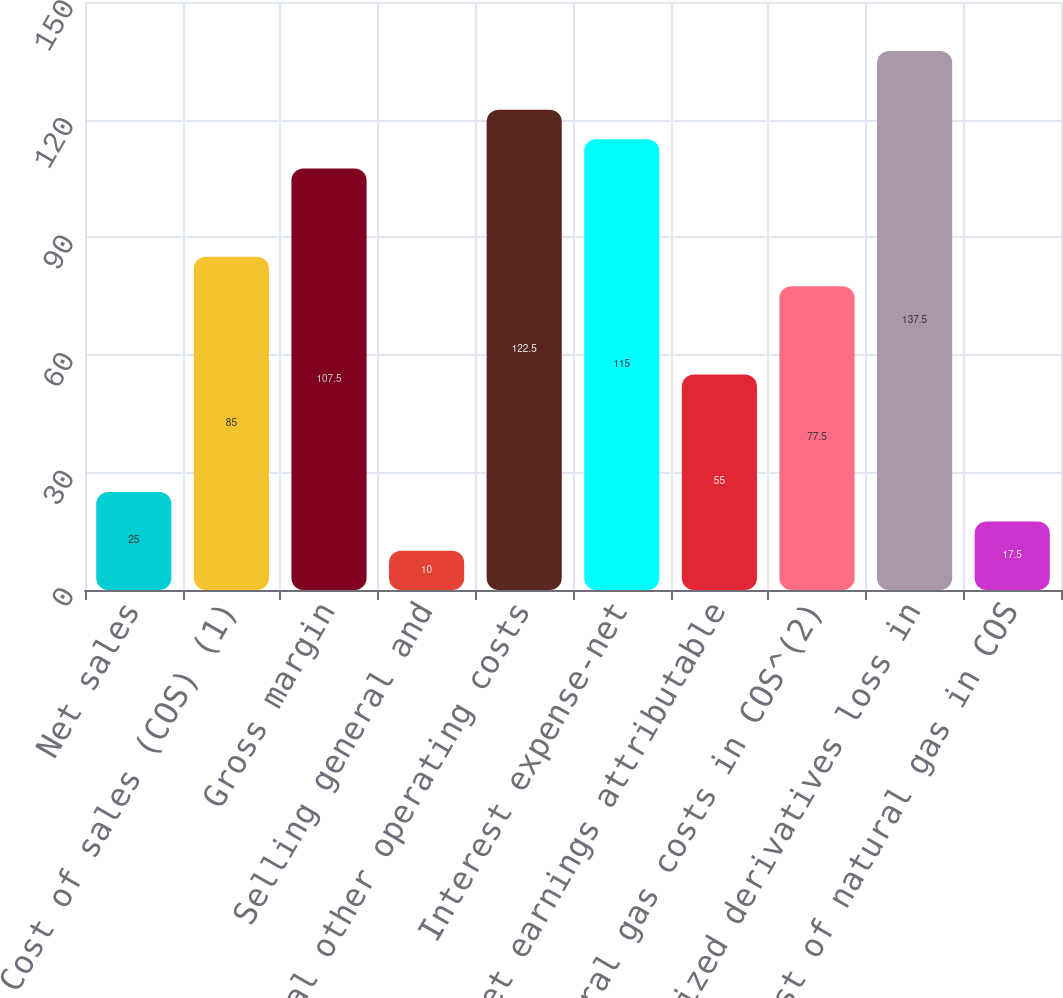<chart> <loc_0><loc_0><loc_500><loc_500><bar_chart><fcel>Net sales<fcel>Cost of sales (COS) (1)<fcel>Gross margin<fcel>Selling general and<fcel>Total other operating costs<fcel>Interest expense-net<fcel>Less Net earnings attributable<fcel>Natural gas costs in COS^(2)<fcel>Realized derivatives loss in<fcel>Cost of natural gas in COS<nl><fcel>25<fcel>85<fcel>107.5<fcel>10<fcel>122.5<fcel>115<fcel>55<fcel>77.5<fcel>137.5<fcel>17.5<nl></chart> 